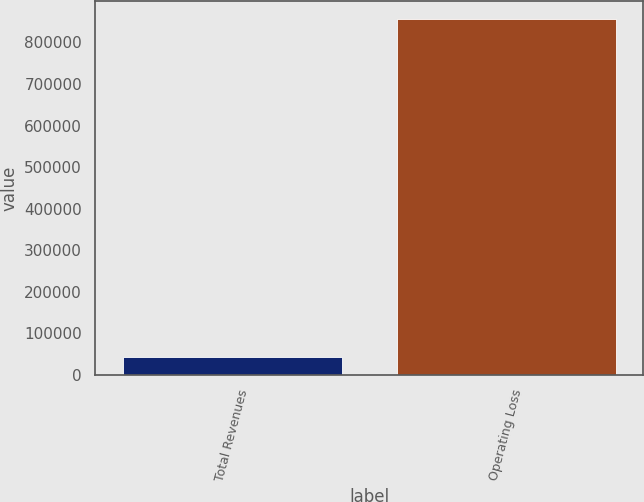Convert chart. <chart><loc_0><loc_0><loc_500><loc_500><bar_chart><fcel>Total Revenues<fcel>Operating Loss<nl><fcel>43831<fcel>856235<nl></chart> 